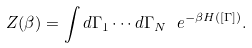<formula> <loc_0><loc_0><loc_500><loc_500>Z ( \beta ) = \int d \Gamma _ { 1 } \cdots d \Gamma _ { N } \ e ^ { - \beta H ( [ \Gamma ] ) } .</formula> 